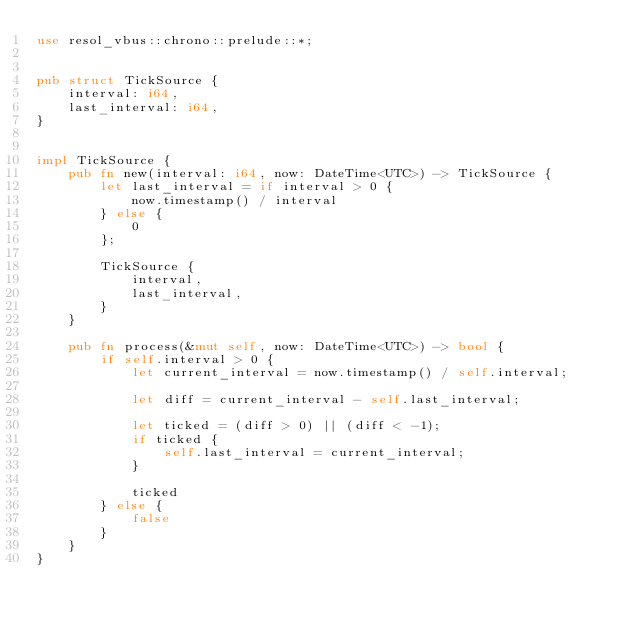<code> <loc_0><loc_0><loc_500><loc_500><_Rust_>use resol_vbus::chrono::prelude::*;


pub struct TickSource {
    interval: i64,
    last_interval: i64,
}


impl TickSource {
    pub fn new(interval: i64, now: DateTime<UTC>) -> TickSource {
        let last_interval = if interval > 0 {
            now.timestamp() / interval
        } else {
            0
        };

        TickSource {
            interval,
            last_interval,
        }
    }

    pub fn process(&mut self, now: DateTime<UTC>) -> bool {
        if self.interval > 0 {
            let current_interval = now.timestamp() / self.interval;

            let diff = current_interval - self.last_interval;

            let ticked = (diff > 0) || (diff < -1);
            if ticked {
                self.last_interval = current_interval;
            }

            ticked
        } else {
            false
        }
    }
}
</code> 